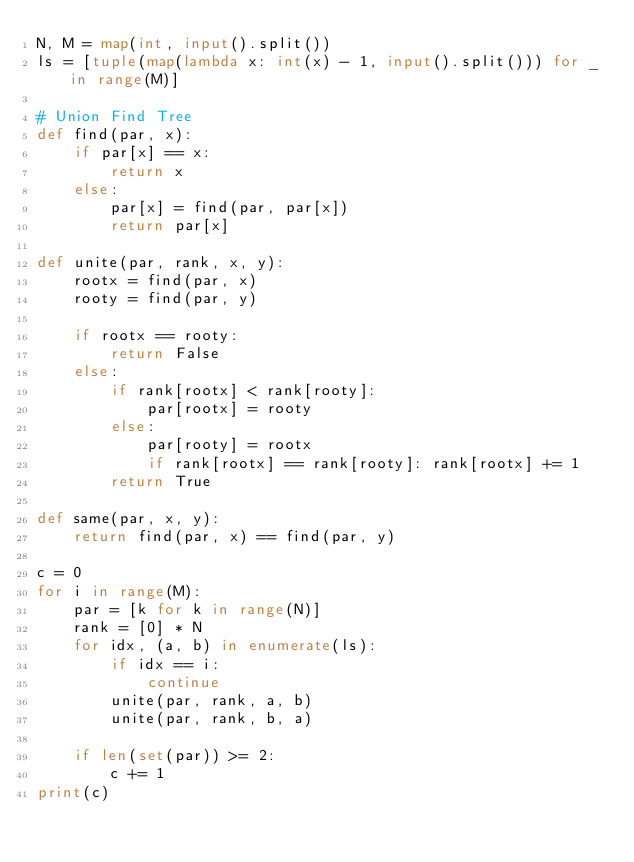<code> <loc_0><loc_0><loc_500><loc_500><_Python_>N, M = map(int, input().split())
ls = [tuple(map(lambda x: int(x) - 1, input().split())) for _ in range(M)]

# Union Find Tree
def find(par, x):
    if par[x] == x:
        return x
    else:
        par[x] = find(par, par[x])
        return par[x]

def unite(par, rank, x, y):
    rootx = find(par, x)
    rooty = find(par, y)

    if rootx == rooty:
        return False
    else:
        if rank[rootx] < rank[rooty]:
            par[rootx] = rooty
        else:
            par[rooty] = rootx
            if rank[rootx] == rank[rooty]: rank[rootx] += 1
        return True

def same(par, x, y):
    return find(par, x) == find(par, y)

c = 0
for i in range(M):
    par = [k for k in range(N)]
    rank = [0] * N
    for idx, (a, b) in enumerate(ls):
        if idx == i:
            continue
        unite(par, rank, a, b)
        unite(par, rank, b, a)
    
    if len(set(par)) >= 2:
        c += 1
print(c)</code> 